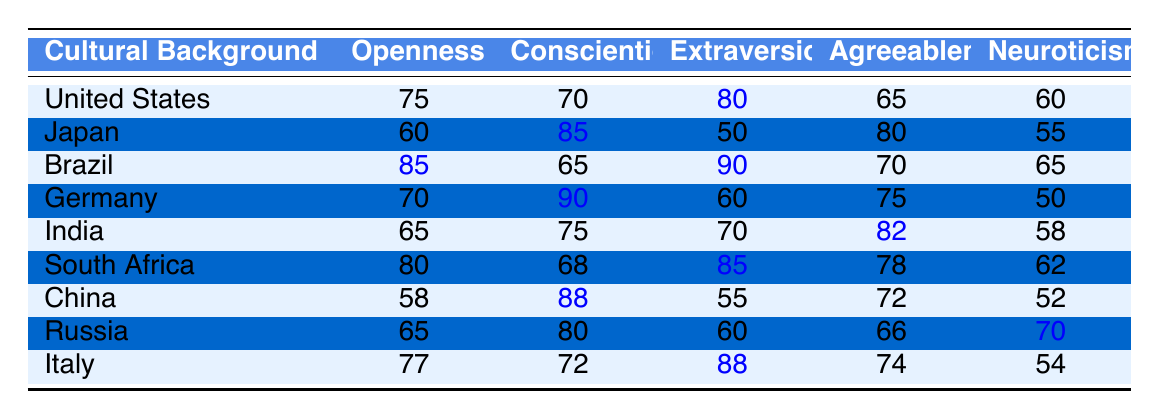What is the average level of extraversion for Brazil? The table shows that the average extraversion for Brazil is 90.
Answer: 90 Which cultural background has the highest average openness? Brazil has the highest average openness score of 85 compared to the others in the table.
Answer: Brazil Is the average conscientiousness score for Germany higher than that for Japan? Germany has an average conscientiousness score of 90, while Japan's is 85, so yes, Germany's score is higher.
Answer: Yes What is the difference in average neuroticism between China and Russia? China has an average neuroticism score of 52 and Russia has 70, so the difference is 70 - 52 = 18.
Answer: 18 Which country has the lowest average score for agreeableness, and what is that score? Japan has the lowest average agreeableness score of 80 compared to other countries.
Answer: Japan, 80 What is the average score for conscientiousness across all countries listed? The scores for conscientiousness are 70, 85, 65, 90, 75, 68, 88, 80, and 72. Summing these gives 70 + 85 + 65 + 90 + 75 + 68 + 88 + 80 + 72 = 774. Dividing by 9 countries gives an average of 774/9 = 86. This results in an average score of approximately 86.
Answer: 86 Which cultural background is least extraverted based on the data? Japan has the lowest average extraversion score of 50 compared to other countries listed.
Answer: Japan Calculate the average score for agreeableness across all cultures represented. The agreeableness scores are 65, 80, 70, 75, 82, 78, 72, 66, and 74. Summing these gives 65 + 80 + 70 + 75 + 82 + 78 + 72 + 66 + 74 =  688. Dividing this total by 9 gives an average of 688/9 = about 76.44.
Answer: 76.44 Does Brazil score higher in average openness than South Africa? Brazil has an average openness score of 85 while South Africa has a score of 80, so Brazil scores higher.
Answer: Yes Which country shows the highest level of neuroticism, and what is that level? Russia shows the highest neuroticism with a score of 70.
Answer: Russia, 70 